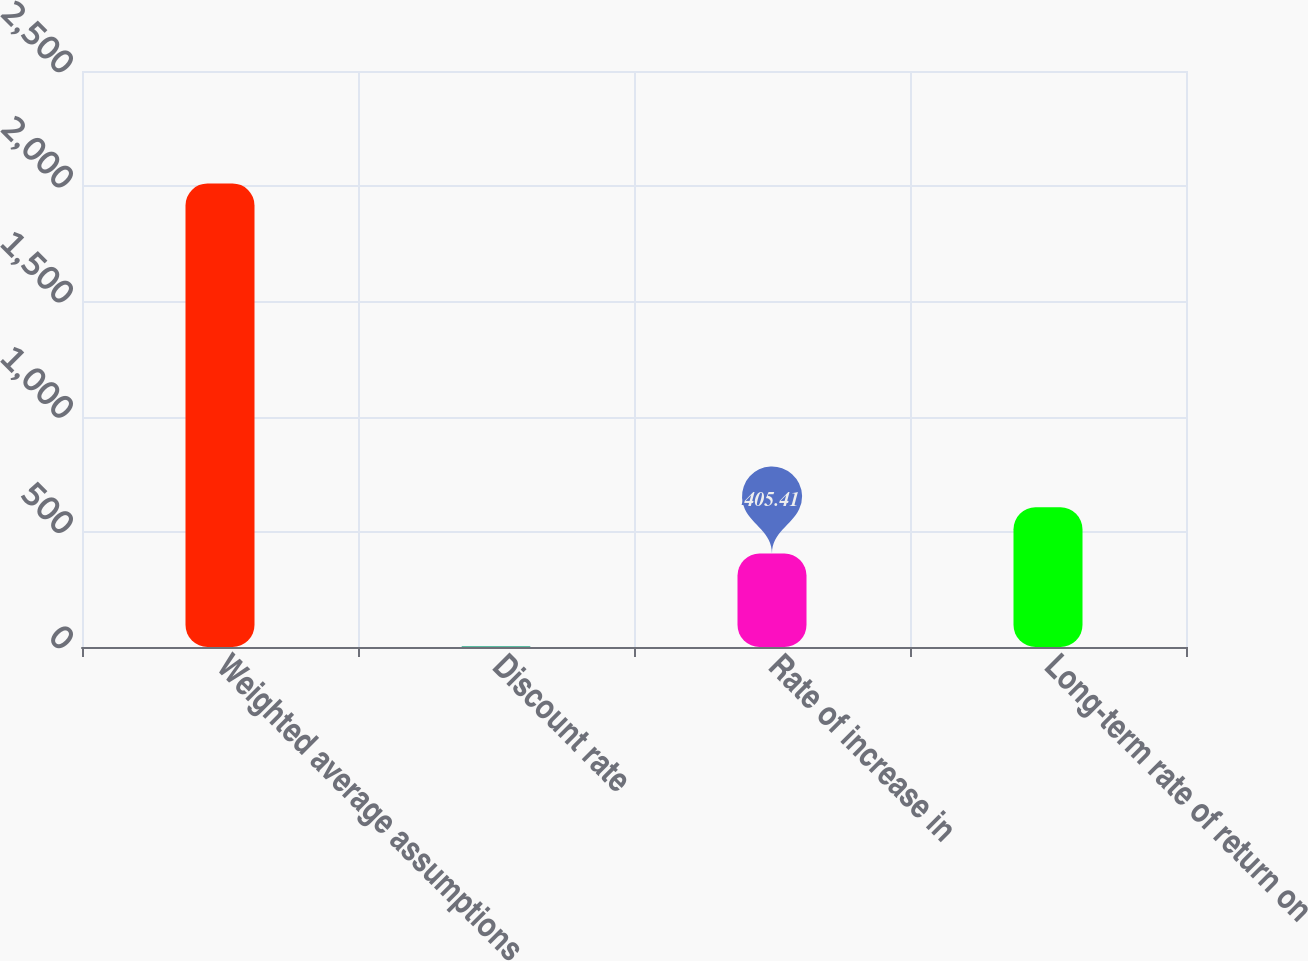Convert chart. <chart><loc_0><loc_0><loc_500><loc_500><bar_chart><fcel>Weighted average assumptions<fcel>Discount rate<fcel>Rate of increase in<fcel>Long-term rate of return on<nl><fcel>2012<fcel>3.75<fcel>405.41<fcel>606.24<nl></chart> 